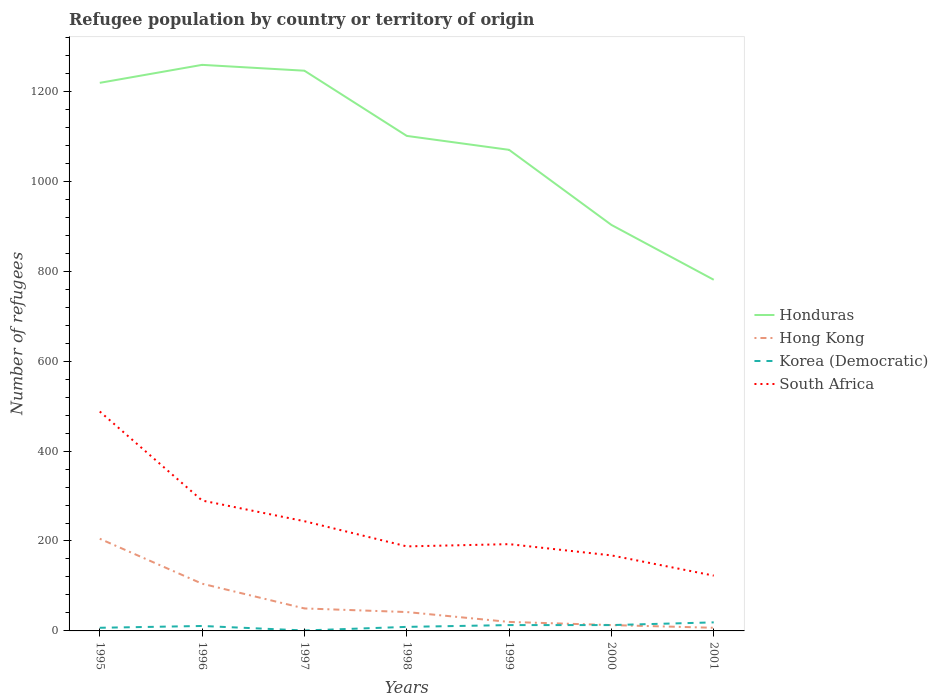How many different coloured lines are there?
Your response must be concise. 4. Is the number of lines equal to the number of legend labels?
Your response must be concise. Yes. Across all years, what is the maximum number of refugees in South Africa?
Your answer should be very brief. 123. What is the total number of refugees in Korea (Democratic) in the graph?
Ensure brevity in your answer.  6. What is the difference between the highest and the lowest number of refugees in South Africa?
Make the answer very short. 3. Is the number of refugees in South Africa strictly greater than the number of refugees in Hong Kong over the years?
Ensure brevity in your answer.  No. How many lines are there?
Ensure brevity in your answer.  4. How many years are there in the graph?
Offer a terse response. 7. What is the difference between two consecutive major ticks on the Y-axis?
Ensure brevity in your answer.  200. Does the graph contain grids?
Offer a very short reply. No. What is the title of the graph?
Keep it short and to the point. Refugee population by country or territory of origin. What is the label or title of the Y-axis?
Give a very brief answer. Number of refugees. What is the Number of refugees in Honduras in 1995?
Provide a short and direct response. 1219. What is the Number of refugees of Hong Kong in 1995?
Give a very brief answer. 205. What is the Number of refugees of South Africa in 1995?
Make the answer very short. 488. What is the Number of refugees of Honduras in 1996?
Keep it short and to the point. 1259. What is the Number of refugees of Hong Kong in 1996?
Offer a terse response. 105. What is the Number of refugees in Korea (Democratic) in 1996?
Your answer should be very brief. 11. What is the Number of refugees in South Africa in 1996?
Your answer should be very brief. 290. What is the Number of refugees in Honduras in 1997?
Offer a very short reply. 1246. What is the Number of refugees of Korea (Democratic) in 1997?
Provide a short and direct response. 1. What is the Number of refugees of South Africa in 1997?
Ensure brevity in your answer.  244. What is the Number of refugees of Honduras in 1998?
Make the answer very short. 1101. What is the Number of refugees in South Africa in 1998?
Keep it short and to the point. 188. What is the Number of refugees of Honduras in 1999?
Give a very brief answer. 1070. What is the Number of refugees of South Africa in 1999?
Ensure brevity in your answer.  193. What is the Number of refugees of Honduras in 2000?
Your answer should be very brief. 903. What is the Number of refugees in Hong Kong in 2000?
Provide a succinct answer. 13. What is the Number of refugees in Korea (Democratic) in 2000?
Make the answer very short. 13. What is the Number of refugees of South Africa in 2000?
Offer a terse response. 168. What is the Number of refugees in Honduras in 2001?
Provide a short and direct response. 781. What is the Number of refugees in Hong Kong in 2001?
Your answer should be very brief. 7. What is the Number of refugees of South Africa in 2001?
Your response must be concise. 123. Across all years, what is the maximum Number of refugees in Honduras?
Make the answer very short. 1259. Across all years, what is the maximum Number of refugees in Hong Kong?
Offer a terse response. 205. Across all years, what is the maximum Number of refugees of Korea (Democratic)?
Ensure brevity in your answer.  19. Across all years, what is the maximum Number of refugees of South Africa?
Your answer should be compact. 488. Across all years, what is the minimum Number of refugees in Honduras?
Your response must be concise. 781. Across all years, what is the minimum Number of refugees of Korea (Democratic)?
Give a very brief answer. 1. Across all years, what is the minimum Number of refugees in South Africa?
Offer a very short reply. 123. What is the total Number of refugees in Honduras in the graph?
Make the answer very short. 7579. What is the total Number of refugees of Hong Kong in the graph?
Provide a succinct answer. 442. What is the total Number of refugees of Korea (Democratic) in the graph?
Make the answer very short. 73. What is the total Number of refugees in South Africa in the graph?
Make the answer very short. 1694. What is the difference between the Number of refugees of Honduras in 1995 and that in 1996?
Give a very brief answer. -40. What is the difference between the Number of refugees in South Africa in 1995 and that in 1996?
Provide a succinct answer. 198. What is the difference between the Number of refugees of Hong Kong in 1995 and that in 1997?
Provide a short and direct response. 155. What is the difference between the Number of refugees in Korea (Democratic) in 1995 and that in 1997?
Your answer should be compact. 6. What is the difference between the Number of refugees in South Africa in 1995 and that in 1997?
Provide a succinct answer. 244. What is the difference between the Number of refugees in Honduras in 1995 and that in 1998?
Offer a very short reply. 118. What is the difference between the Number of refugees in Hong Kong in 1995 and that in 1998?
Give a very brief answer. 163. What is the difference between the Number of refugees in South Africa in 1995 and that in 1998?
Make the answer very short. 300. What is the difference between the Number of refugees of Honduras in 1995 and that in 1999?
Give a very brief answer. 149. What is the difference between the Number of refugees in Hong Kong in 1995 and that in 1999?
Your answer should be compact. 185. What is the difference between the Number of refugees of Korea (Democratic) in 1995 and that in 1999?
Provide a short and direct response. -6. What is the difference between the Number of refugees of South Africa in 1995 and that in 1999?
Ensure brevity in your answer.  295. What is the difference between the Number of refugees of Honduras in 1995 and that in 2000?
Keep it short and to the point. 316. What is the difference between the Number of refugees of Hong Kong in 1995 and that in 2000?
Ensure brevity in your answer.  192. What is the difference between the Number of refugees in South Africa in 1995 and that in 2000?
Your answer should be compact. 320. What is the difference between the Number of refugees in Honduras in 1995 and that in 2001?
Offer a very short reply. 438. What is the difference between the Number of refugees in Hong Kong in 1995 and that in 2001?
Make the answer very short. 198. What is the difference between the Number of refugees of South Africa in 1995 and that in 2001?
Ensure brevity in your answer.  365. What is the difference between the Number of refugees of South Africa in 1996 and that in 1997?
Your answer should be very brief. 46. What is the difference between the Number of refugees in Honduras in 1996 and that in 1998?
Your answer should be compact. 158. What is the difference between the Number of refugees of Hong Kong in 1996 and that in 1998?
Keep it short and to the point. 63. What is the difference between the Number of refugees of South Africa in 1996 and that in 1998?
Your answer should be compact. 102. What is the difference between the Number of refugees of Honduras in 1996 and that in 1999?
Ensure brevity in your answer.  189. What is the difference between the Number of refugees in Hong Kong in 1996 and that in 1999?
Make the answer very short. 85. What is the difference between the Number of refugees of Korea (Democratic) in 1996 and that in 1999?
Give a very brief answer. -2. What is the difference between the Number of refugees in South Africa in 1996 and that in 1999?
Offer a terse response. 97. What is the difference between the Number of refugees of Honduras in 1996 and that in 2000?
Keep it short and to the point. 356. What is the difference between the Number of refugees of Hong Kong in 1996 and that in 2000?
Your response must be concise. 92. What is the difference between the Number of refugees of Korea (Democratic) in 1996 and that in 2000?
Ensure brevity in your answer.  -2. What is the difference between the Number of refugees in South Africa in 1996 and that in 2000?
Give a very brief answer. 122. What is the difference between the Number of refugees in Honduras in 1996 and that in 2001?
Provide a short and direct response. 478. What is the difference between the Number of refugees of Korea (Democratic) in 1996 and that in 2001?
Ensure brevity in your answer.  -8. What is the difference between the Number of refugees of South Africa in 1996 and that in 2001?
Keep it short and to the point. 167. What is the difference between the Number of refugees of Honduras in 1997 and that in 1998?
Offer a very short reply. 145. What is the difference between the Number of refugees of Korea (Democratic) in 1997 and that in 1998?
Offer a very short reply. -8. What is the difference between the Number of refugees of South Africa in 1997 and that in 1998?
Your answer should be compact. 56. What is the difference between the Number of refugees of Honduras in 1997 and that in 1999?
Your response must be concise. 176. What is the difference between the Number of refugees in South Africa in 1997 and that in 1999?
Your response must be concise. 51. What is the difference between the Number of refugees in Honduras in 1997 and that in 2000?
Give a very brief answer. 343. What is the difference between the Number of refugees in Honduras in 1997 and that in 2001?
Ensure brevity in your answer.  465. What is the difference between the Number of refugees in Korea (Democratic) in 1997 and that in 2001?
Offer a very short reply. -18. What is the difference between the Number of refugees of South Africa in 1997 and that in 2001?
Your response must be concise. 121. What is the difference between the Number of refugees of Korea (Democratic) in 1998 and that in 1999?
Offer a terse response. -4. What is the difference between the Number of refugees in Honduras in 1998 and that in 2000?
Offer a very short reply. 198. What is the difference between the Number of refugees in Hong Kong in 1998 and that in 2000?
Your answer should be very brief. 29. What is the difference between the Number of refugees in Korea (Democratic) in 1998 and that in 2000?
Keep it short and to the point. -4. What is the difference between the Number of refugees of Honduras in 1998 and that in 2001?
Offer a terse response. 320. What is the difference between the Number of refugees of Korea (Democratic) in 1998 and that in 2001?
Your response must be concise. -10. What is the difference between the Number of refugees in Honduras in 1999 and that in 2000?
Provide a short and direct response. 167. What is the difference between the Number of refugees in Hong Kong in 1999 and that in 2000?
Offer a terse response. 7. What is the difference between the Number of refugees in Korea (Democratic) in 1999 and that in 2000?
Your response must be concise. 0. What is the difference between the Number of refugees in Honduras in 1999 and that in 2001?
Your answer should be very brief. 289. What is the difference between the Number of refugees in Honduras in 2000 and that in 2001?
Make the answer very short. 122. What is the difference between the Number of refugees of Korea (Democratic) in 2000 and that in 2001?
Keep it short and to the point. -6. What is the difference between the Number of refugees in Honduras in 1995 and the Number of refugees in Hong Kong in 1996?
Ensure brevity in your answer.  1114. What is the difference between the Number of refugees of Honduras in 1995 and the Number of refugees of Korea (Democratic) in 1996?
Provide a short and direct response. 1208. What is the difference between the Number of refugees of Honduras in 1995 and the Number of refugees of South Africa in 1996?
Your answer should be very brief. 929. What is the difference between the Number of refugees in Hong Kong in 1995 and the Number of refugees in Korea (Democratic) in 1996?
Your response must be concise. 194. What is the difference between the Number of refugees of Hong Kong in 1995 and the Number of refugees of South Africa in 1996?
Provide a succinct answer. -85. What is the difference between the Number of refugees of Korea (Democratic) in 1995 and the Number of refugees of South Africa in 1996?
Your answer should be very brief. -283. What is the difference between the Number of refugees of Honduras in 1995 and the Number of refugees of Hong Kong in 1997?
Ensure brevity in your answer.  1169. What is the difference between the Number of refugees of Honduras in 1995 and the Number of refugees of Korea (Democratic) in 1997?
Offer a terse response. 1218. What is the difference between the Number of refugees of Honduras in 1995 and the Number of refugees of South Africa in 1997?
Your response must be concise. 975. What is the difference between the Number of refugees in Hong Kong in 1995 and the Number of refugees in Korea (Democratic) in 1997?
Make the answer very short. 204. What is the difference between the Number of refugees of Hong Kong in 1995 and the Number of refugees of South Africa in 1997?
Your answer should be very brief. -39. What is the difference between the Number of refugees of Korea (Democratic) in 1995 and the Number of refugees of South Africa in 1997?
Keep it short and to the point. -237. What is the difference between the Number of refugees in Honduras in 1995 and the Number of refugees in Hong Kong in 1998?
Your response must be concise. 1177. What is the difference between the Number of refugees of Honduras in 1995 and the Number of refugees of Korea (Democratic) in 1998?
Your answer should be compact. 1210. What is the difference between the Number of refugees of Honduras in 1995 and the Number of refugees of South Africa in 1998?
Your answer should be compact. 1031. What is the difference between the Number of refugees in Hong Kong in 1995 and the Number of refugees in Korea (Democratic) in 1998?
Keep it short and to the point. 196. What is the difference between the Number of refugees of Hong Kong in 1995 and the Number of refugees of South Africa in 1998?
Provide a short and direct response. 17. What is the difference between the Number of refugees in Korea (Democratic) in 1995 and the Number of refugees in South Africa in 1998?
Offer a very short reply. -181. What is the difference between the Number of refugees in Honduras in 1995 and the Number of refugees in Hong Kong in 1999?
Offer a terse response. 1199. What is the difference between the Number of refugees of Honduras in 1995 and the Number of refugees of Korea (Democratic) in 1999?
Your response must be concise. 1206. What is the difference between the Number of refugees in Honduras in 1995 and the Number of refugees in South Africa in 1999?
Provide a succinct answer. 1026. What is the difference between the Number of refugees of Hong Kong in 1995 and the Number of refugees of Korea (Democratic) in 1999?
Keep it short and to the point. 192. What is the difference between the Number of refugees of Hong Kong in 1995 and the Number of refugees of South Africa in 1999?
Your answer should be compact. 12. What is the difference between the Number of refugees of Korea (Democratic) in 1995 and the Number of refugees of South Africa in 1999?
Give a very brief answer. -186. What is the difference between the Number of refugees of Honduras in 1995 and the Number of refugees of Hong Kong in 2000?
Offer a very short reply. 1206. What is the difference between the Number of refugees of Honduras in 1995 and the Number of refugees of Korea (Democratic) in 2000?
Your answer should be very brief. 1206. What is the difference between the Number of refugees in Honduras in 1995 and the Number of refugees in South Africa in 2000?
Offer a terse response. 1051. What is the difference between the Number of refugees of Hong Kong in 1995 and the Number of refugees of Korea (Democratic) in 2000?
Offer a very short reply. 192. What is the difference between the Number of refugees in Korea (Democratic) in 1995 and the Number of refugees in South Africa in 2000?
Provide a short and direct response. -161. What is the difference between the Number of refugees in Honduras in 1995 and the Number of refugees in Hong Kong in 2001?
Provide a short and direct response. 1212. What is the difference between the Number of refugees in Honduras in 1995 and the Number of refugees in Korea (Democratic) in 2001?
Offer a terse response. 1200. What is the difference between the Number of refugees of Honduras in 1995 and the Number of refugees of South Africa in 2001?
Your response must be concise. 1096. What is the difference between the Number of refugees of Hong Kong in 1995 and the Number of refugees of Korea (Democratic) in 2001?
Offer a terse response. 186. What is the difference between the Number of refugees in Korea (Democratic) in 1995 and the Number of refugees in South Africa in 2001?
Offer a terse response. -116. What is the difference between the Number of refugees of Honduras in 1996 and the Number of refugees of Hong Kong in 1997?
Give a very brief answer. 1209. What is the difference between the Number of refugees in Honduras in 1996 and the Number of refugees in Korea (Democratic) in 1997?
Your response must be concise. 1258. What is the difference between the Number of refugees in Honduras in 1996 and the Number of refugees in South Africa in 1997?
Offer a terse response. 1015. What is the difference between the Number of refugees of Hong Kong in 1996 and the Number of refugees of Korea (Democratic) in 1997?
Your answer should be very brief. 104. What is the difference between the Number of refugees in Hong Kong in 1996 and the Number of refugees in South Africa in 1997?
Make the answer very short. -139. What is the difference between the Number of refugees in Korea (Democratic) in 1996 and the Number of refugees in South Africa in 1997?
Ensure brevity in your answer.  -233. What is the difference between the Number of refugees of Honduras in 1996 and the Number of refugees of Hong Kong in 1998?
Provide a short and direct response. 1217. What is the difference between the Number of refugees of Honduras in 1996 and the Number of refugees of Korea (Democratic) in 1998?
Provide a short and direct response. 1250. What is the difference between the Number of refugees in Honduras in 1996 and the Number of refugees in South Africa in 1998?
Keep it short and to the point. 1071. What is the difference between the Number of refugees in Hong Kong in 1996 and the Number of refugees in Korea (Democratic) in 1998?
Offer a terse response. 96. What is the difference between the Number of refugees in Hong Kong in 1996 and the Number of refugees in South Africa in 1998?
Offer a very short reply. -83. What is the difference between the Number of refugees in Korea (Democratic) in 1996 and the Number of refugees in South Africa in 1998?
Keep it short and to the point. -177. What is the difference between the Number of refugees of Honduras in 1996 and the Number of refugees of Hong Kong in 1999?
Your answer should be compact. 1239. What is the difference between the Number of refugees in Honduras in 1996 and the Number of refugees in Korea (Democratic) in 1999?
Keep it short and to the point. 1246. What is the difference between the Number of refugees in Honduras in 1996 and the Number of refugees in South Africa in 1999?
Give a very brief answer. 1066. What is the difference between the Number of refugees in Hong Kong in 1996 and the Number of refugees in Korea (Democratic) in 1999?
Provide a succinct answer. 92. What is the difference between the Number of refugees of Hong Kong in 1996 and the Number of refugees of South Africa in 1999?
Provide a succinct answer. -88. What is the difference between the Number of refugees of Korea (Democratic) in 1996 and the Number of refugees of South Africa in 1999?
Offer a terse response. -182. What is the difference between the Number of refugees in Honduras in 1996 and the Number of refugees in Hong Kong in 2000?
Ensure brevity in your answer.  1246. What is the difference between the Number of refugees of Honduras in 1996 and the Number of refugees of Korea (Democratic) in 2000?
Your response must be concise. 1246. What is the difference between the Number of refugees of Honduras in 1996 and the Number of refugees of South Africa in 2000?
Your answer should be compact. 1091. What is the difference between the Number of refugees of Hong Kong in 1996 and the Number of refugees of Korea (Democratic) in 2000?
Keep it short and to the point. 92. What is the difference between the Number of refugees in Hong Kong in 1996 and the Number of refugees in South Africa in 2000?
Provide a short and direct response. -63. What is the difference between the Number of refugees in Korea (Democratic) in 1996 and the Number of refugees in South Africa in 2000?
Your response must be concise. -157. What is the difference between the Number of refugees in Honduras in 1996 and the Number of refugees in Hong Kong in 2001?
Your answer should be compact. 1252. What is the difference between the Number of refugees of Honduras in 1996 and the Number of refugees of Korea (Democratic) in 2001?
Your answer should be compact. 1240. What is the difference between the Number of refugees of Honduras in 1996 and the Number of refugees of South Africa in 2001?
Make the answer very short. 1136. What is the difference between the Number of refugees of Hong Kong in 1996 and the Number of refugees of Korea (Democratic) in 2001?
Offer a very short reply. 86. What is the difference between the Number of refugees of Korea (Democratic) in 1996 and the Number of refugees of South Africa in 2001?
Keep it short and to the point. -112. What is the difference between the Number of refugees in Honduras in 1997 and the Number of refugees in Hong Kong in 1998?
Make the answer very short. 1204. What is the difference between the Number of refugees of Honduras in 1997 and the Number of refugees of Korea (Democratic) in 1998?
Provide a short and direct response. 1237. What is the difference between the Number of refugees in Honduras in 1997 and the Number of refugees in South Africa in 1998?
Provide a succinct answer. 1058. What is the difference between the Number of refugees of Hong Kong in 1997 and the Number of refugees of South Africa in 1998?
Your response must be concise. -138. What is the difference between the Number of refugees of Korea (Democratic) in 1997 and the Number of refugees of South Africa in 1998?
Offer a very short reply. -187. What is the difference between the Number of refugees in Honduras in 1997 and the Number of refugees in Hong Kong in 1999?
Keep it short and to the point. 1226. What is the difference between the Number of refugees of Honduras in 1997 and the Number of refugees of Korea (Democratic) in 1999?
Your answer should be compact. 1233. What is the difference between the Number of refugees in Honduras in 1997 and the Number of refugees in South Africa in 1999?
Your answer should be compact. 1053. What is the difference between the Number of refugees of Hong Kong in 1997 and the Number of refugees of Korea (Democratic) in 1999?
Your answer should be compact. 37. What is the difference between the Number of refugees in Hong Kong in 1997 and the Number of refugees in South Africa in 1999?
Your answer should be compact. -143. What is the difference between the Number of refugees in Korea (Democratic) in 1997 and the Number of refugees in South Africa in 1999?
Offer a very short reply. -192. What is the difference between the Number of refugees of Honduras in 1997 and the Number of refugees of Hong Kong in 2000?
Keep it short and to the point. 1233. What is the difference between the Number of refugees in Honduras in 1997 and the Number of refugees in Korea (Democratic) in 2000?
Your response must be concise. 1233. What is the difference between the Number of refugees of Honduras in 1997 and the Number of refugees of South Africa in 2000?
Give a very brief answer. 1078. What is the difference between the Number of refugees of Hong Kong in 1997 and the Number of refugees of Korea (Democratic) in 2000?
Your answer should be very brief. 37. What is the difference between the Number of refugees of Hong Kong in 1997 and the Number of refugees of South Africa in 2000?
Provide a succinct answer. -118. What is the difference between the Number of refugees of Korea (Democratic) in 1997 and the Number of refugees of South Africa in 2000?
Ensure brevity in your answer.  -167. What is the difference between the Number of refugees of Honduras in 1997 and the Number of refugees of Hong Kong in 2001?
Make the answer very short. 1239. What is the difference between the Number of refugees of Honduras in 1997 and the Number of refugees of Korea (Democratic) in 2001?
Offer a very short reply. 1227. What is the difference between the Number of refugees in Honduras in 1997 and the Number of refugees in South Africa in 2001?
Your response must be concise. 1123. What is the difference between the Number of refugees of Hong Kong in 1997 and the Number of refugees of Korea (Democratic) in 2001?
Your answer should be compact. 31. What is the difference between the Number of refugees of Hong Kong in 1997 and the Number of refugees of South Africa in 2001?
Your answer should be very brief. -73. What is the difference between the Number of refugees in Korea (Democratic) in 1997 and the Number of refugees in South Africa in 2001?
Ensure brevity in your answer.  -122. What is the difference between the Number of refugees in Honduras in 1998 and the Number of refugees in Hong Kong in 1999?
Offer a very short reply. 1081. What is the difference between the Number of refugees of Honduras in 1998 and the Number of refugees of Korea (Democratic) in 1999?
Provide a short and direct response. 1088. What is the difference between the Number of refugees in Honduras in 1998 and the Number of refugees in South Africa in 1999?
Make the answer very short. 908. What is the difference between the Number of refugees of Hong Kong in 1998 and the Number of refugees of South Africa in 1999?
Your answer should be very brief. -151. What is the difference between the Number of refugees in Korea (Democratic) in 1998 and the Number of refugees in South Africa in 1999?
Provide a succinct answer. -184. What is the difference between the Number of refugees in Honduras in 1998 and the Number of refugees in Hong Kong in 2000?
Provide a succinct answer. 1088. What is the difference between the Number of refugees in Honduras in 1998 and the Number of refugees in Korea (Democratic) in 2000?
Your response must be concise. 1088. What is the difference between the Number of refugees of Honduras in 1998 and the Number of refugees of South Africa in 2000?
Offer a very short reply. 933. What is the difference between the Number of refugees of Hong Kong in 1998 and the Number of refugees of South Africa in 2000?
Provide a succinct answer. -126. What is the difference between the Number of refugees in Korea (Democratic) in 1998 and the Number of refugees in South Africa in 2000?
Make the answer very short. -159. What is the difference between the Number of refugees of Honduras in 1998 and the Number of refugees of Hong Kong in 2001?
Your response must be concise. 1094. What is the difference between the Number of refugees in Honduras in 1998 and the Number of refugees in Korea (Democratic) in 2001?
Your answer should be very brief. 1082. What is the difference between the Number of refugees in Honduras in 1998 and the Number of refugees in South Africa in 2001?
Provide a succinct answer. 978. What is the difference between the Number of refugees of Hong Kong in 1998 and the Number of refugees of Korea (Democratic) in 2001?
Your answer should be very brief. 23. What is the difference between the Number of refugees of Hong Kong in 1998 and the Number of refugees of South Africa in 2001?
Provide a short and direct response. -81. What is the difference between the Number of refugees in Korea (Democratic) in 1998 and the Number of refugees in South Africa in 2001?
Provide a succinct answer. -114. What is the difference between the Number of refugees of Honduras in 1999 and the Number of refugees of Hong Kong in 2000?
Your response must be concise. 1057. What is the difference between the Number of refugees of Honduras in 1999 and the Number of refugees of Korea (Democratic) in 2000?
Your answer should be compact. 1057. What is the difference between the Number of refugees of Honduras in 1999 and the Number of refugees of South Africa in 2000?
Keep it short and to the point. 902. What is the difference between the Number of refugees of Hong Kong in 1999 and the Number of refugees of Korea (Democratic) in 2000?
Your response must be concise. 7. What is the difference between the Number of refugees in Hong Kong in 1999 and the Number of refugees in South Africa in 2000?
Provide a short and direct response. -148. What is the difference between the Number of refugees in Korea (Democratic) in 1999 and the Number of refugees in South Africa in 2000?
Ensure brevity in your answer.  -155. What is the difference between the Number of refugees of Honduras in 1999 and the Number of refugees of Hong Kong in 2001?
Your answer should be very brief. 1063. What is the difference between the Number of refugees of Honduras in 1999 and the Number of refugees of Korea (Democratic) in 2001?
Make the answer very short. 1051. What is the difference between the Number of refugees in Honduras in 1999 and the Number of refugees in South Africa in 2001?
Your response must be concise. 947. What is the difference between the Number of refugees in Hong Kong in 1999 and the Number of refugees in South Africa in 2001?
Your response must be concise. -103. What is the difference between the Number of refugees of Korea (Democratic) in 1999 and the Number of refugees of South Africa in 2001?
Offer a terse response. -110. What is the difference between the Number of refugees of Honduras in 2000 and the Number of refugees of Hong Kong in 2001?
Give a very brief answer. 896. What is the difference between the Number of refugees of Honduras in 2000 and the Number of refugees of Korea (Democratic) in 2001?
Ensure brevity in your answer.  884. What is the difference between the Number of refugees in Honduras in 2000 and the Number of refugees in South Africa in 2001?
Provide a short and direct response. 780. What is the difference between the Number of refugees in Hong Kong in 2000 and the Number of refugees in Korea (Democratic) in 2001?
Your answer should be very brief. -6. What is the difference between the Number of refugees in Hong Kong in 2000 and the Number of refugees in South Africa in 2001?
Offer a terse response. -110. What is the difference between the Number of refugees in Korea (Democratic) in 2000 and the Number of refugees in South Africa in 2001?
Make the answer very short. -110. What is the average Number of refugees of Honduras per year?
Your answer should be very brief. 1082.71. What is the average Number of refugees of Hong Kong per year?
Ensure brevity in your answer.  63.14. What is the average Number of refugees in Korea (Democratic) per year?
Ensure brevity in your answer.  10.43. What is the average Number of refugees in South Africa per year?
Provide a succinct answer. 242. In the year 1995, what is the difference between the Number of refugees of Honduras and Number of refugees of Hong Kong?
Keep it short and to the point. 1014. In the year 1995, what is the difference between the Number of refugees in Honduras and Number of refugees in Korea (Democratic)?
Give a very brief answer. 1212. In the year 1995, what is the difference between the Number of refugees in Honduras and Number of refugees in South Africa?
Your answer should be compact. 731. In the year 1995, what is the difference between the Number of refugees in Hong Kong and Number of refugees in Korea (Democratic)?
Your answer should be compact. 198. In the year 1995, what is the difference between the Number of refugees in Hong Kong and Number of refugees in South Africa?
Offer a terse response. -283. In the year 1995, what is the difference between the Number of refugees of Korea (Democratic) and Number of refugees of South Africa?
Make the answer very short. -481. In the year 1996, what is the difference between the Number of refugees in Honduras and Number of refugees in Hong Kong?
Give a very brief answer. 1154. In the year 1996, what is the difference between the Number of refugees in Honduras and Number of refugees in Korea (Democratic)?
Offer a very short reply. 1248. In the year 1996, what is the difference between the Number of refugees of Honduras and Number of refugees of South Africa?
Keep it short and to the point. 969. In the year 1996, what is the difference between the Number of refugees in Hong Kong and Number of refugees in Korea (Democratic)?
Offer a terse response. 94. In the year 1996, what is the difference between the Number of refugees in Hong Kong and Number of refugees in South Africa?
Ensure brevity in your answer.  -185. In the year 1996, what is the difference between the Number of refugees in Korea (Democratic) and Number of refugees in South Africa?
Offer a very short reply. -279. In the year 1997, what is the difference between the Number of refugees in Honduras and Number of refugees in Hong Kong?
Give a very brief answer. 1196. In the year 1997, what is the difference between the Number of refugees of Honduras and Number of refugees of Korea (Democratic)?
Your response must be concise. 1245. In the year 1997, what is the difference between the Number of refugees in Honduras and Number of refugees in South Africa?
Make the answer very short. 1002. In the year 1997, what is the difference between the Number of refugees in Hong Kong and Number of refugees in Korea (Democratic)?
Your answer should be compact. 49. In the year 1997, what is the difference between the Number of refugees of Hong Kong and Number of refugees of South Africa?
Make the answer very short. -194. In the year 1997, what is the difference between the Number of refugees in Korea (Democratic) and Number of refugees in South Africa?
Your answer should be very brief. -243. In the year 1998, what is the difference between the Number of refugees in Honduras and Number of refugees in Hong Kong?
Provide a succinct answer. 1059. In the year 1998, what is the difference between the Number of refugees in Honduras and Number of refugees in Korea (Democratic)?
Your answer should be very brief. 1092. In the year 1998, what is the difference between the Number of refugees of Honduras and Number of refugees of South Africa?
Offer a very short reply. 913. In the year 1998, what is the difference between the Number of refugees of Hong Kong and Number of refugees of South Africa?
Your answer should be compact. -146. In the year 1998, what is the difference between the Number of refugees in Korea (Democratic) and Number of refugees in South Africa?
Offer a terse response. -179. In the year 1999, what is the difference between the Number of refugees in Honduras and Number of refugees in Hong Kong?
Provide a short and direct response. 1050. In the year 1999, what is the difference between the Number of refugees of Honduras and Number of refugees of Korea (Democratic)?
Give a very brief answer. 1057. In the year 1999, what is the difference between the Number of refugees in Honduras and Number of refugees in South Africa?
Your answer should be very brief. 877. In the year 1999, what is the difference between the Number of refugees of Hong Kong and Number of refugees of South Africa?
Your answer should be compact. -173. In the year 1999, what is the difference between the Number of refugees of Korea (Democratic) and Number of refugees of South Africa?
Provide a short and direct response. -180. In the year 2000, what is the difference between the Number of refugees in Honduras and Number of refugees in Hong Kong?
Your answer should be compact. 890. In the year 2000, what is the difference between the Number of refugees in Honduras and Number of refugees in Korea (Democratic)?
Offer a very short reply. 890. In the year 2000, what is the difference between the Number of refugees in Honduras and Number of refugees in South Africa?
Your answer should be compact. 735. In the year 2000, what is the difference between the Number of refugees of Hong Kong and Number of refugees of South Africa?
Your answer should be very brief. -155. In the year 2000, what is the difference between the Number of refugees in Korea (Democratic) and Number of refugees in South Africa?
Make the answer very short. -155. In the year 2001, what is the difference between the Number of refugees of Honduras and Number of refugees of Hong Kong?
Offer a very short reply. 774. In the year 2001, what is the difference between the Number of refugees of Honduras and Number of refugees of Korea (Democratic)?
Your answer should be very brief. 762. In the year 2001, what is the difference between the Number of refugees in Honduras and Number of refugees in South Africa?
Provide a short and direct response. 658. In the year 2001, what is the difference between the Number of refugees of Hong Kong and Number of refugees of South Africa?
Ensure brevity in your answer.  -116. In the year 2001, what is the difference between the Number of refugees in Korea (Democratic) and Number of refugees in South Africa?
Your answer should be very brief. -104. What is the ratio of the Number of refugees of Honduras in 1995 to that in 1996?
Provide a short and direct response. 0.97. What is the ratio of the Number of refugees of Hong Kong in 1995 to that in 1996?
Ensure brevity in your answer.  1.95. What is the ratio of the Number of refugees of Korea (Democratic) in 1995 to that in 1996?
Your answer should be very brief. 0.64. What is the ratio of the Number of refugees of South Africa in 1995 to that in 1996?
Offer a terse response. 1.68. What is the ratio of the Number of refugees of Honduras in 1995 to that in 1997?
Your answer should be very brief. 0.98. What is the ratio of the Number of refugees in Honduras in 1995 to that in 1998?
Your answer should be very brief. 1.11. What is the ratio of the Number of refugees in Hong Kong in 1995 to that in 1998?
Your answer should be compact. 4.88. What is the ratio of the Number of refugees in South Africa in 1995 to that in 1998?
Your answer should be very brief. 2.6. What is the ratio of the Number of refugees in Honduras in 1995 to that in 1999?
Make the answer very short. 1.14. What is the ratio of the Number of refugees in Hong Kong in 1995 to that in 1999?
Offer a very short reply. 10.25. What is the ratio of the Number of refugees of Korea (Democratic) in 1995 to that in 1999?
Provide a succinct answer. 0.54. What is the ratio of the Number of refugees of South Africa in 1995 to that in 1999?
Offer a very short reply. 2.53. What is the ratio of the Number of refugees of Honduras in 1995 to that in 2000?
Provide a succinct answer. 1.35. What is the ratio of the Number of refugees in Hong Kong in 1995 to that in 2000?
Offer a very short reply. 15.77. What is the ratio of the Number of refugees in Korea (Democratic) in 1995 to that in 2000?
Your answer should be compact. 0.54. What is the ratio of the Number of refugees of South Africa in 1995 to that in 2000?
Provide a short and direct response. 2.9. What is the ratio of the Number of refugees in Honduras in 1995 to that in 2001?
Ensure brevity in your answer.  1.56. What is the ratio of the Number of refugees of Hong Kong in 1995 to that in 2001?
Ensure brevity in your answer.  29.29. What is the ratio of the Number of refugees in Korea (Democratic) in 1995 to that in 2001?
Provide a succinct answer. 0.37. What is the ratio of the Number of refugees of South Africa in 1995 to that in 2001?
Your answer should be compact. 3.97. What is the ratio of the Number of refugees of Honduras in 1996 to that in 1997?
Your response must be concise. 1.01. What is the ratio of the Number of refugees of Hong Kong in 1996 to that in 1997?
Keep it short and to the point. 2.1. What is the ratio of the Number of refugees of South Africa in 1996 to that in 1997?
Your answer should be compact. 1.19. What is the ratio of the Number of refugees of Honduras in 1996 to that in 1998?
Provide a short and direct response. 1.14. What is the ratio of the Number of refugees in Korea (Democratic) in 1996 to that in 1998?
Your answer should be compact. 1.22. What is the ratio of the Number of refugees in South Africa in 1996 to that in 1998?
Make the answer very short. 1.54. What is the ratio of the Number of refugees in Honduras in 1996 to that in 1999?
Provide a short and direct response. 1.18. What is the ratio of the Number of refugees of Hong Kong in 1996 to that in 1999?
Your response must be concise. 5.25. What is the ratio of the Number of refugees of Korea (Democratic) in 1996 to that in 1999?
Offer a terse response. 0.85. What is the ratio of the Number of refugees of South Africa in 1996 to that in 1999?
Provide a short and direct response. 1.5. What is the ratio of the Number of refugees in Honduras in 1996 to that in 2000?
Make the answer very short. 1.39. What is the ratio of the Number of refugees in Hong Kong in 1996 to that in 2000?
Offer a very short reply. 8.08. What is the ratio of the Number of refugees of Korea (Democratic) in 1996 to that in 2000?
Provide a short and direct response. 0.85. What is the ratio of the Number of refugees in South Africa in 1996 to that in 2000?
Your answer should be compact. 1.73. What is the ratio of the Number of refugees of Honduras in 1996 to that in 2001?
Your response must be concise. 1.61. What is the ratio of the Number of refugees in Hong Kong in 1996 to that in 2001?
Provide a succinct answer. 15. What is the ratio of the Number of refugees in Korea (Democratic) in 1996 to that in 2001?
Your answer should be compact. 0.58. What is the ratio of the Number of refugees of South Africa in 1996 to that in 2001?
Your answer should be compact. 2.36. What is the ratio of the Number of refugees of Honduras in 1997 to that in 1998?
Give a very brief answer. 1.13. What is the ratio of the Number of refugees in Hong Kong in 1997 to that in 1998?
Keep it short and to the point. 1.19. What is the ratio of the Number of refugees in South Africa in 1997 to that in 1998?
Your answer should be very brief. 1.3. What is the ratio of the Number of refugees of Honduras in 1997 to that in 1999?
Offer a terse response. 1.16. What is the ratio of the Number of refugees in Korea (Democratic) in 1997 to that in 1999?
Your response must be concise. 0.08. What is the ratio of the Number of refugees in South Africa in 1997 to that in 1999?
Give a very brief answer. 1.26. What is the ratio of the Number of refugees in Honduras in 1997 to that in 2000?
Offer a terse response. 1.38. What is the ratio of the Number of refugees in Hong Kong in 1997 to that in 2000?
Give a very brief answer. 3.85. What is the ratio of the Number of refugees of Korea (Democratic) in 1997 to that in 2000?
Ensure brevity in your answer.  0.08. What is the ratio of the Number of refugees in South Africa in 1997 to that in 2000?
Your response must be concise. 1.45. What is the ratio of the Number of refugees in Honduras in 1997 to that in 2001?
Offer a very short reply. 1.6. What is the ratio of the Number of refugees in Hong Kong in 1997 to that in 2001?
Provide a short and direct response. 7.14. What is the ratio of the Number of refugees of Korea (Democratic) in 1997 to that in 2001?
Make the answer very short. 0.05. What is the ratio of the Number of refugees in South Africa in 1997 to that in 2001?
Your answer should be compact. 1.98. What is the ratio of the Number of refugees in Honduras in 1998 to that in 1999?
Offer a very short reply. 1.03. What is the ratio of the Number of refugees of Hong Kong in 1998 to that in 1999?
Provide a short and direct response. 2.1. What is the ratio of the Number of refugees of Korea (Democratic) in 1998 to that in 1999?
Provide a succinct answer. 0.69. What is the ratio of the Number of refugees of South Africa in 1998 to that in 1999?
Make the answer very short. 0.97. What is the ratio of the Number of refugees in Honduras in 1998 to that in 2000?
Your response must be concise. 1.22. What is the ratio of the Number of refugees of Hong Kong in 1998 to that in 2000?
Your answer should be very brief. 3.23. What is the ratio of the Number of refugees of Korea (Democratic) in 1998 to that in 2000?
Keep it short and to the point. 0.69. What is the ratio of the Number of refugees in South Africa in 1998 to that in 2000?
Provide a short and direct response. 1.12. What is the ratio of the Number of refugees of Honduras in 1998 to that in 2001?
Provide a short and direct response. 1.41. What is the ratio of the Number of refugees of Hong Kong in 1998 to that in 2001?
Your response must be concise. 6. What is the ratio of the Number of refugees of Korea (Democratic) in 1998 to that in 2001?
Your answer should be very brief. 0.47. What is the ratio of the Number of refugees in South Africa in 1998 to that in 2001?
Your response must be concise. 1.53. What is the ratio of the Number of refugees of Honduras in 1999 to that in 2000?
Provide a succinct answer. 1.18. What is the ratio of the Number of refugees in Hong Kong in 1999 to that in 2000?
Your response must be concise. 1.54. What is the ratio of the Number of refugees of Korea (Democratic) in 1999 to that in 2000?
Provide a succinct answer. 1. What is the ratio of the Number of refugees in South Africa in 1999 to that in 2000?
Provide a succinct answer. 1.15. What is the ratio of the Number of refugees of Honduras in 1999 to that in 2001?
Your response must be concise. 1.37. What is the ratio of the Number of refugees in Hong Kong in 1999 to that in 2001?
Provide a short and direct response. 2.86. What is the ratio of the Number of refugees in Korea (Democratic) in 1999 to that in 2001?
Make the answer very short. 0.68. What is the ratio of the Number of refugees of South Africa in 1999 to that in 2001?
Offer a very short reply. 1.57. What is the ratio of the Number of refugees in Honduras in 2000 to that in 2001?
Make the answer very short. 1.16. What is the ratio of the Number of refugees in Hong Kong in 2000 to that in 2001?
Ensure brevity in your answer.  1.86. What is the ratio of the Number of refugees of Korea (Democratic) in 2000 to that in 2001?
Your answer should be compact. 0.68. What is the ratio of the Number of refugees of South Africa in 2000 to that in 2001?
Give a very brief answer. 1.37. What is the difference between the highest and the second highest Number of refugees in Honduras?
Ensure brevity in your answer.  13. What is the difference between the highest and the second highest Number of refugees of Hong Kong?
Your response must be concise. 100. What is the difference between the highest and the second highest Number of refugees in South Africa?
Keep it short and to the point. 198. What is the difference between the highest and the lowest Number of refugees of Honduras?
Give a very brief answer. 478. What is the difference between the highest and the lowest Number of refugees of Hong Kong?
Ensure brevity in your answer.  198. What is the difference between the highest and the lowest Number of refugees of Korea (Democratic)?
Keep it short and to the point. 18. What is the difference between the highest and the lowest Number of refugees in South Africa?
Offer a terse response. 365. 